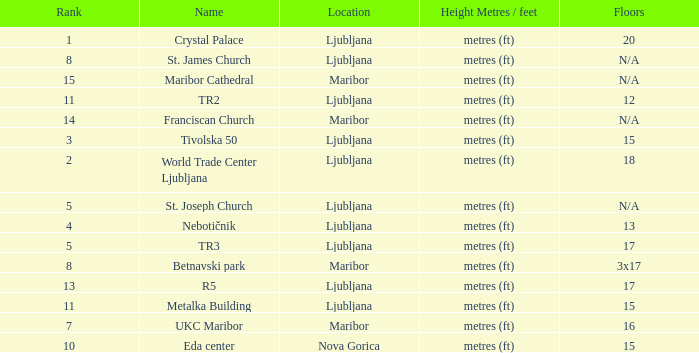Which Floors have a Location of ljubljana, and a Name of tr3? 17.0. 